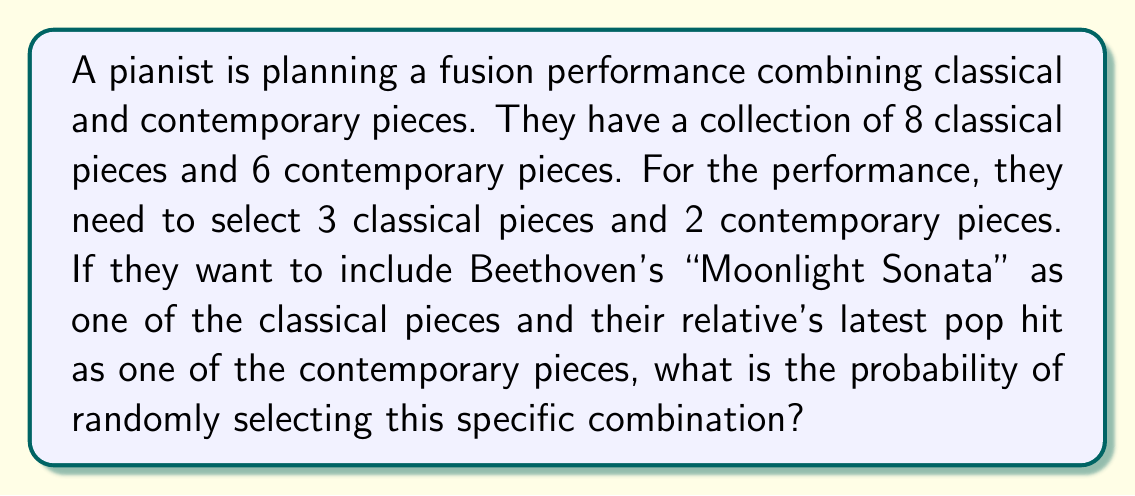Solve this math problem. Let's approach this step-by-step:

1) First, we need to calculate the total number of possible combinations:
   - We need to choose 3 out of 8 classical pieces: $\binom{8}{3}$
   - We need to choose 2 out of 6 contemporary pieces: $\binom{6}{2}$
   - Total number of combinations: $\binom{8}{3} \cdot \binom{6}{2}$

2) Now, let's calculate these combinations:
   $\binom{8}{3} = \frac{8!}{3!(8-3)!} = \frac{8!}{3!5!} = 56$
   $\binom{6}{2} = \frac{6!}{2!(6-2)!} = \frac{6!}{2!4!} = 15$

3) Total number of combinations: $56 \cdot 15 = 840$

4) For the specific combination we want:
   - "Moonlight Sonata" is already chosen, so we need to choose 2 more from the remaining 7 classical pieces: $\binom{7}{2}$
   - The relative's pop hit is already chosen, so we need to choose 1 more from the remaining 5 contemporary pieces: $\binom{5}{1}$

5) Calculate these combinations:
   $\binom{7}{2} = \frac{7!}{2!(7-2)!} = \frac{7!}{2!5!} = 21$
   $\binom{5}{1} = \frac{5!}{1!(5-1)!} = \frac{5!}{1!4!} = 5$

6) Number of favorable outcomes: $21 \cdot 5 = 105$

7) Probability = (Favorable outcomes) / (Total outcomes)
   $= \frac{105}{840} = \frac{1}{8}$
Answer: $\frac{1}{8}$ 